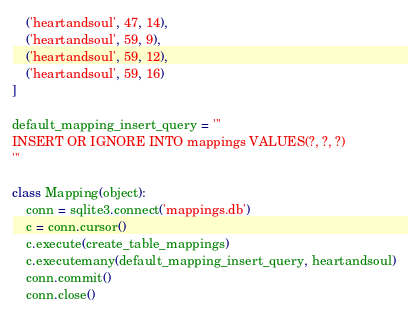Convert code to text. <code><loc_0><loc_0><loc_500><loc_500><_Python_>    ('heartandsoul', 47, 14),
    ('heartandsoul', 59, 9),
    ('heartandsoul', 59, 12),
    ('heartandsoul', 59, 16)
]

default_mapping_insert_query = '''
INSERT OR IGNORE INTO mappings VALUES(?, ?, ?)
'''

class Mapping(object):
    conn = sqlite3.connect('mappings.db')
    c = conn.cursor()
    c.execute(create_table_mappings)
    c.executemany(default_mapping_insert_query, heartandsoul)
    conn.commit()
    conn.close()
</code> 